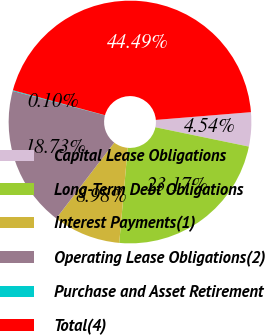Convert chart to OTSL. <chart><loc_0><loc_0><loc_500><loc_500><pie_chart><fcel>Capital Lease Obligations<fcel>Long-Term Debt Obligations<fcel>Interest Payments(1)<fcel>Operating Lease Obligations(2)<fcel>Purchase and Asset Retirement<fcel>Total(4)<nl><fcel>4.54%<fcel>23.17%<fcel>8.98%<fcel>18.73%<fcel>0.1%<fcel>44.49%<nl></chart> 